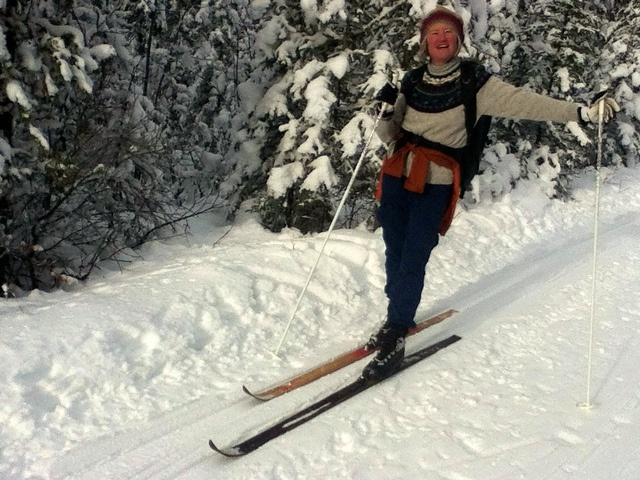Describe the objects in this image and their specific colors. I can see people in gray, black, and maroon tones, backpack in gray and black tones, skis in gray, black, and darkgray tones, and skis in gray and brown tones in this image. 